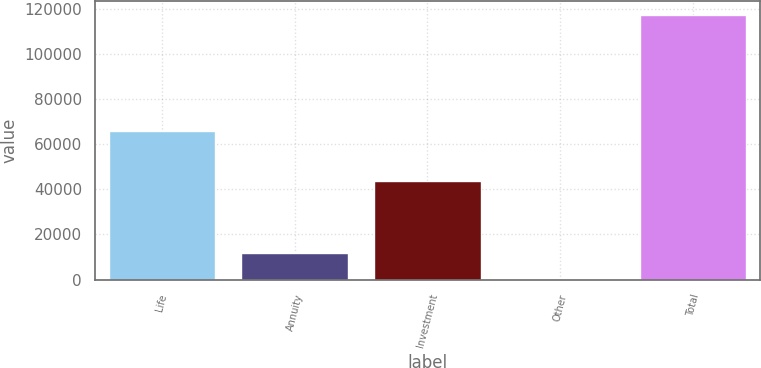<chart> <loc_0><loc_0><loc_500><loc_500><bar_chart><fcel>Life<fcel>Annuity<fcel>Investment<fcel>Other<fcel>Total<nl><fcel>65726<fcel>11849.2<fcel>43787<fcel>103<fcel>117565<nl></chart> 